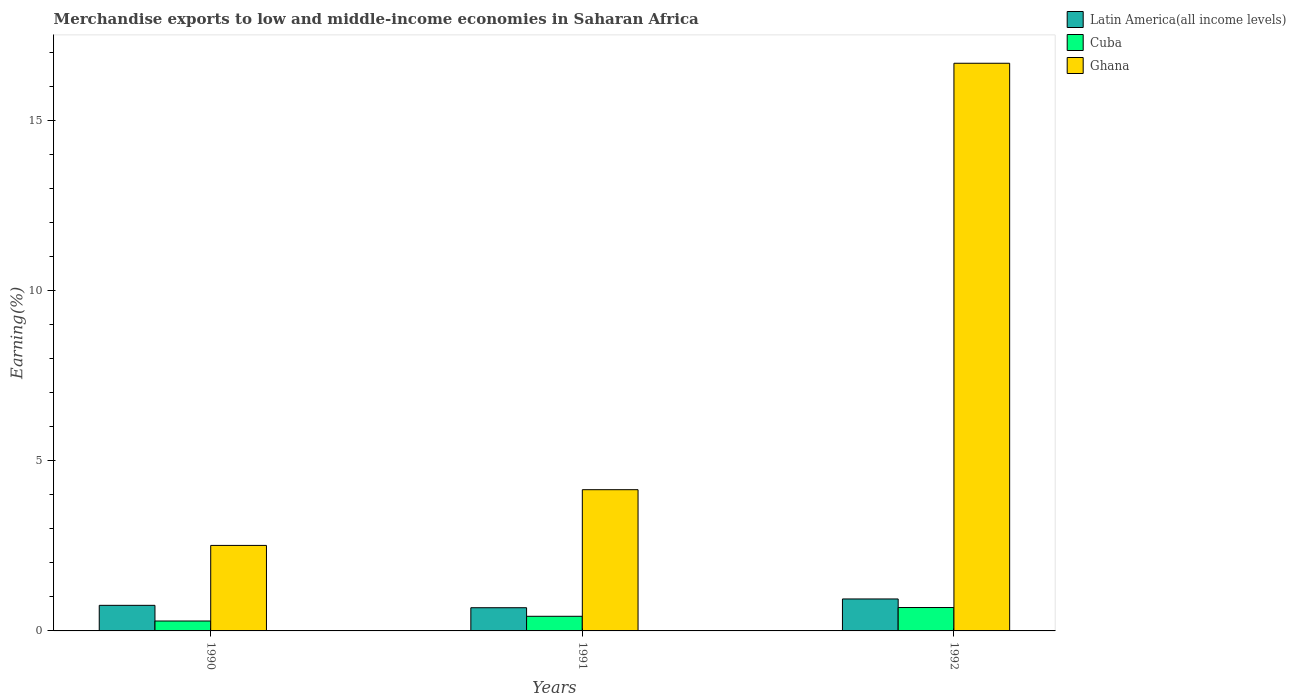How many different coloured bars are there?
Your answer should be compact. 3. How many groups of bars are there?
Provide a succinct answer. 3. Are the number of bars on each tick of the X-axis equal?
Keep it short and to the point. Yes. How many bars are there on the 3rd tick from the right?
Your response must be concise. 3. What is the label of the 3rd group of bars from the left?
Give a very brief answer. 1992. In how many cases, is the number of bars for a given year not equal to the number of legend labels?
Give a very brief answer. 0. What is the percentage of amount earned from merchandise exports in Latin America(all income levels) in 1992?
Offer a very short reply. 0.94. Across all years, what is the maximum percentage of amount earned from merchandise exports in Latin America(all income levels)?
Your answer should be very brief. 0.94. Across all years, what is the minimum percentage of amount earned from merchandise exports in Cuba?
Your answer should be very brief. 0.29. In which year was the percentage of amount earned from merchandise exports in Latin America(all income levels) maximum?
Provide a short and direct response. 1992. What is the total percentage of amount earned from merchandise exports in Latin America(all income levels) in the graph?
Provide a short and direct response. 2.37. What is the difference between the percentage of amount earned from merchandise exports in Cuba in 1991 and that in 1992?
Provide a succinct answer. -0.26. What is the difference between the percentage of amount earned from merchandise exports in Cuba in 1992 and the percentage of amount earned from merchandise exports in Ghana in 1990?
Your answer should be compact. -1.82. What is the average percentage of amount earned from merchandise exports in Cuba per year?
Provide a short and direct response. 0.47. In the year 1992, what is the difference between the percentage of amount earned from merchandise exports in Ghana and percentage of amount earned from merchandise exports in Cuba?
Your answer should be very brief. 15.98. What is the ratio of the percentage of amount earned from merchandise exports in Ghana in 1991 to that in 1992?
Your answer should be very brief. 0.25. What is the difference between the highest and the second highest percentage of amount earned from merchandise exports in Latin America(all income levels)?
Your response must be concise. 0.19. What is the difference between the highest and the lowest percentage of amount earned from merchandise exports in Ghana?
Provide a succinct answer. 14.16. What does the 3rd bar from the left in 1990 represents?
Provide a short and direct response. Ghana. What does the 3rd bar from the right in 1990 represents?
Provide a short and direct response. Latin America(all income levels). Is it the case that in every year, the sum of the percentage of amount earned from merchandise exports in Cuba and percentage of amount earned from merchandise exports in Latin America(all income levels) is greater than the percentage of amount earned from merchandise exports in Ghana?
Keep it short and to the point. No. How many bars are there?
Give a very brief answer. 9. Are all the bars in the graph horizontal?
Offer a terse response. No. How many years are there in the graph?
Provide a short and direct response. 3. What is the difference between two consecutive major ticks on the Y-axis?
Your answer should be compact. 5. How many legend labels are there?
Your answer should be very brief. 3. What is the title of the graph?
Offer a very short reply. Merchandise exports to low and middle-income economies in Saharan Africa. What is the label or title of the Y-axis?
Offer a very short reply. Earning(%). What is the Earning(%) of Latin America(all income levels) in 1990?
Your answer should be very brief. 0.75. What is the Earning(%) in Cuba in 1990?
Provide a succinct answer. 0.29. What is the Earning(%) of Ghana in 1990?
Provide a succinct answer. 2.51. What is the Earning(%) in Latin America(all income levels) in 1991?
Provide a succinct answer. 0.68. What is the Earning(%) of Cuba in 1991?
Your response must be concise. 0.43. What is the Earning(%) in Ghana in 1991?
Provide a short and direct response. 4.15. What is the Earning(%) in Latin America(all income levels) in 1992?
Offer a very short reply. 0.94. What is the Earning(%) in Cuba in 1992?
Ensure brevity in your answer.  0.69. What is the Earning(%) of Ghana in 1992?
Offer a very short reply. 16.67. Across all years, what is the maximum Earning(%) of Latin America(all income levels)?
Your response must be concise. 0.94. Across all years, what is the maximum Earning(%) of Cuba?
Provide a short and direct response. 0.69. Across all years, what is the maximum Earning(%) of Ghana?
Ensure brevity in your answer.  16.67. Across all years, what is the minimum Earning(%) of Latin America(all income levels)?
Give a very brief answer. 0.68. Across all years, what is the minimum Earning(%) of Cuba?
Keep it short and to the point. 0.29. Across all years, what is the minimum Earning(%) of Ghana?
Make the answer very short. 2.51. What is the total Earning(%) in Latin America(all income levels) in the graph?
Offer a terse response. 2.37. What is the total Earning(%) of Cuba in the graph?
Your answer should be compact. 1.41. What is the total Earning(%) of Ghana in the graph?
Your answer should be compact. 23.33. What is the difference between the Earning(%) in Latin America(all income levels) in 1990 and that in 1991?
Your answer should be compact. 0.07. What is the difference between the Earning(%) in Cuba in 1990 and that in 1991?
Ensure brevity in your answer.  -0.14. What is the difference between the Earning(%) in Ghana in 1990 and that in 1991?
Give a very brief answer. -1.64. What is the difference between the Earning(%) of Latin America(all income levels) in 1990 and that in 1992?
Ensure brevity in your answer.  -0.19. What is the difference between the Earning(%) of Cuba in 1990 and that in 1992?
Ensure brevity in your answer.  -0.4. What is the difference between the Earning(%) of Ghana in 1990 and that in 1992?
Your response must be concise. -14.16. What is the difference between the Earning(%) of Latin America(all income levels) in 1991 and that in 1992?
Offer a terse response. -0.26. What is the difference between the Earning(%) in Cuba in 1991 and that in 1992?
Your answer should be very brief. -0.26. What is the difference between the Earning(%) of Ghana in 1991 and that in 1992?
Provide a succinct answer. -12.52. What is the difference between the Earning(%) in Latin America(all income levels) in 1990 and the Earning(%) in Cuba in 1991?
Make the answer very short. 0.32. What is the difference between the Earning(%) of Latin America(all income levels) in 1990 and the Earning(%) of Ghana in 1991?
Your response must be concise. -3.4. What is the difference between the Earning(%) in Cuba in 1990 and the Earning(%) in Ghana in 1991?
Ensure brevity in your answer.  -3.86. What is the difference between the Earning(%) in Latin America(all income levels) in 1990 and the Earning(%) in Cuba in 1992?
Your answer should be compact. 0.06. What is the difference between the Earning(%) of Latin America(all income levels) in 1990 and the Earning(%) of Ghana in 1992?
Your answer should be very brief. -15.92. What is the difference between the Earning(%) of Cuba in 1990 and the Earning(%) of Ghana in 1992?
Ensure brevity in your answer.  -16.38. What is the difference between the Earning(%) of Latin America(all income levels) in 1991 and the Earning(%) of Cuba in 1992?
Keep it short and to the point. -0.01. What is the difference between the Earning(%) of Latin America(all income levels) in 1991 and the Earning(%) of Ghana in 1992?
Your response must be concise. -15.99. What is the difference between the Earning(%) of Cuba in 1991 and the Earning(%) of Ghana in 1992?
Ensure brevity in your answer.  -16.24. What is the average Earning(%) of Latin America(all income levels) per year?
Ensure brevity in your answer.  0.79. What is the average Earning(%) in Cuba per year?
Keep it short and to the point. 0.47. What is the average Earning(%) of Ghana per year?
Your answer should be compact. 7.78. In the year 1990, what is the difference between the Earning(%) of Latin America(all income levels) and Earning(%) of Cuba?
Offer a very short reply. 0.46. In the year 1990, what is the difference between the Earning(%) of Latin America(all income levels) and Earning(%) of Ghana?
Your answer should be compact. -1.76. In the year 1990, what is the difference between the Earning(%) of Cuba and Earning(%) of Ghana?
Your answer should be very brief. -2.22. In the year 1991, what is the difference between the Earning(%) in Latin America(all income levels) and Earning(%) in Cuba?
Provide a short and direct response. 0.25. In the year 1991, what is the difference between the Earning(%) of Latin America(all income levels) and Earning(%) of Ghana?
Your answer should be compact. -3.47. In the year 1991, what is the difference between the Earning(%) of Cuba and Earning(%) of Ghana?
Make the answer very short. -3.72. In the year 1992, what is the difference between the Earning(%) of Latin America(all income levels) and Earning(%) of Cuba?
Your answer should be compact. 0.25. In the year 1992, what is the difference between the Earning(%) of Latin America(all income levels) and Earning(%) of Ghana?
Provide a short and direct response. -15.73. In the year 1992, what is the difference between the Earning(%) of Cuba and Earning(%) of Ghana?
Make the answer very short. -15.98. What is the ratio of the Earning(%) of Latin America(all income levels) in 1990 to that in 1991?
Provide a short and direct response. 1.1. What is the ratio of the Earning(%) of Cuba in 1990 to that in 1991?
Provide a short and direct response. 0.68. What is the ratio of the Earning(%) of Ghana in 1990 to that in 1991?
Your response must be concise. 0.61. What is the ratio of the Earning(%) in Latin America(all income levels) in 1990 to that in 1992?
Give a very brief answer. 0.8. What is the ratio of the Earning(%) of Cuba in 1990 to that in 1992?
Keep it short and to the point. 0.42. What is the ratio of the Earning(%) of Ghana in 1990 to that in 1992?
Provide a short and direct response. 0.15. What is the ratio of the Earning(%) in Latin America(all income levels) in 1991 to that in 1992?
Provide a short and direct response. 0.73. What is the ratio of the Earning(%) of Cuba in 1991 to that in 1992?
Offer a very short reply. 0.63. What is the ratio of the Earning(%) of Ghana in 1991 to that in 1992?
Ensure brevity in your answer.  0.25. What is the difference between the highest and the second highest Earning(%) of Latin America(all income levels)?
Keep it short and to the point. 0.19. What is the difference between the highest and the second highest Earning(%) in Cuba?
Make the answer very short. 0.26. What is the difference between the highest and the second highest Earning(%) of Ghana?
Provide a short and direct response. 12.52. What is the difference between the highest and the lowest Earning(%) of Latin America(all income levels)?
Provide a short and direct response. 0.26. What is the difference between the highest and the lowest Earning(%) in Cuba?
Give a very brief answer. 0.4. What is the difference between the highest and the lowest Earning(%) of Ghana?
Give a very brief answer. 14.16. 